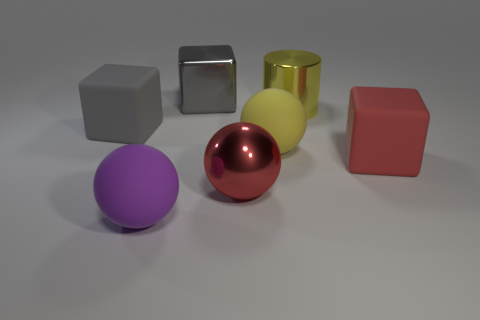Subtract all matte blocks. How many blocks are left? 1 Add 3 large red metal objects. How many objects exist? 10 Subtract all yellow spheres. How many spheres are left? 2 Subtract all cylinders. How many objects are left? 6 Subtract all yellow balls. How many gray cubes are left? 2 Subtract 2 blocks. How many blocks are left? 1 Subtract 0 yellow cubes. How many objects are left? 7 Subtract all brown balls. Subtract all cyan cylinders. How many balls are left? 3 Subtract all brown shiny blocks. Subtract all large metal cubes. How many objects are left? 6 Add 3 gray blocks. How many gray blocks are left? 5 